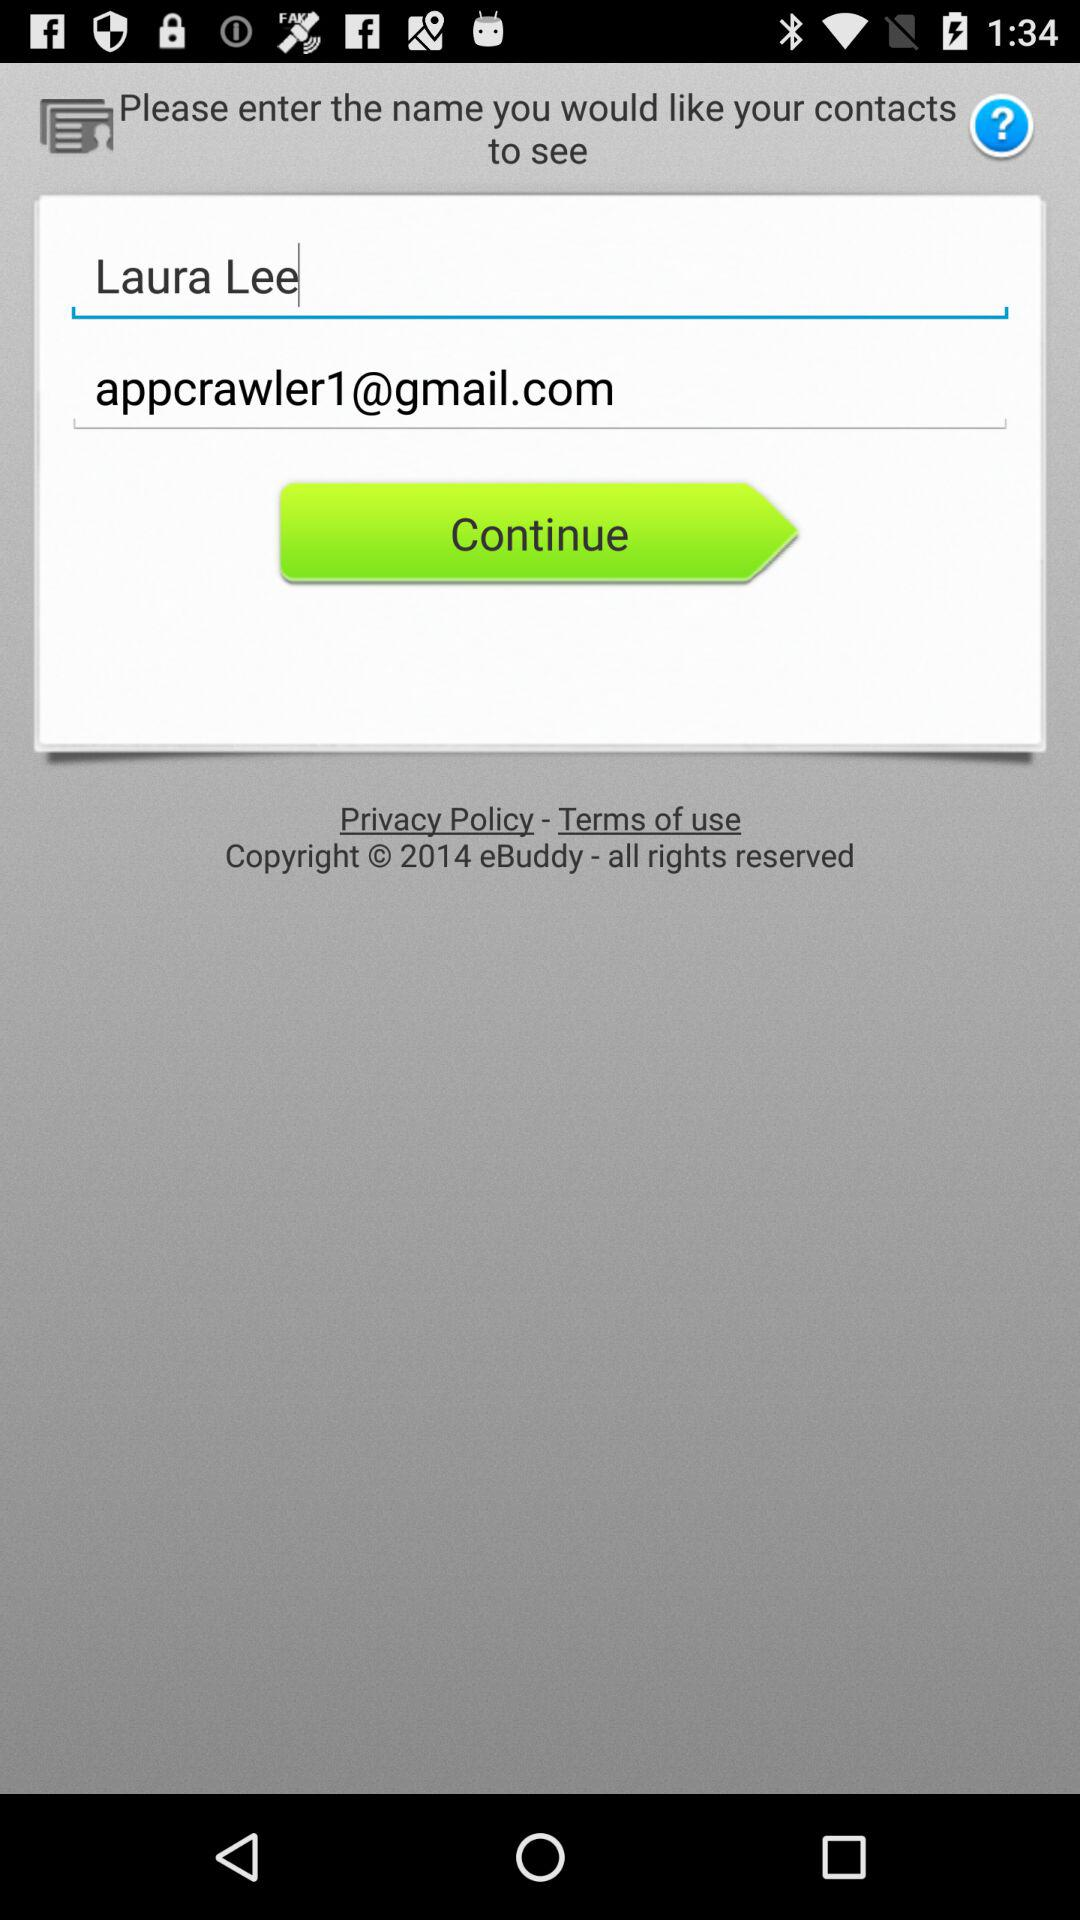What's the user name? The user name is Laura Lee. 